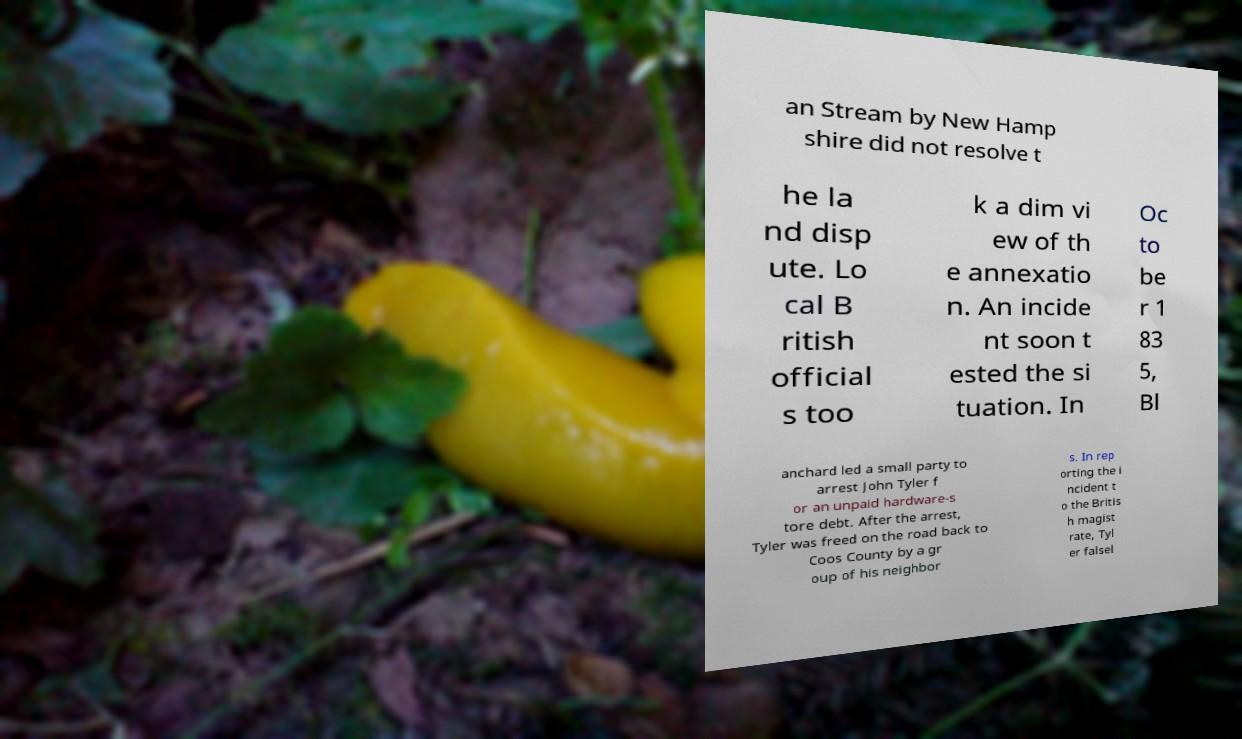Can you accurately transcribe the text from the provided image for me? an Stream by New Hamp shire did not resolve t he la nd disp ute. Lo cal B ritish official s too k a dim vi ew of th e annexatio n. An incide nt soon t ested the si tuation. In Oc to be r 1 83 5, Bl anchard led a small party to arrest John Tyler f or an unpaid hardware-s tore debt. After the arrest, Tyler was freed on the road back to Coos County by a gr oup of his neighbor s. In rep orting the i ncident t o the Britis h magist rate, Tyl er falsel 